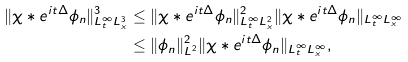Convert formula to latex. <formula><loc_0><loc_0><loc_500><loc_500>\| \chi * e ^ { i t \Delta } \phi _ { n } \| _ { L _ { t } ^ { \infty } L _ { x } ^ { 3 } } ^ { 3 } & \leq \| \chi * e ^ { i t \Delta } \phi _ { n } \| _ { L _ { t } ^ { \infty } L _ { x } ^ { 2 } } ^ { 2 } \| \chi * e ^ { i t \Delta } \phi _ { n } \| _ { L _ { t } ^ { \infty } L _ { x } ^ { \infty } } \\ & \leq \| \phi _ { n } \| _ { L ^ { 2 } } ^ { 2 } \| \chi * e ^ { i t \Delta } \phi _ { n } \| _ { L _ { t } ^ { \infty } L _ { x } ^ { \infty } } ,</formula> 